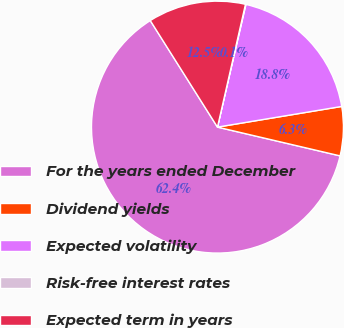Convert chart. <chart><loc_0><loc_0><loc_500><loc_500><pie_chart><fcel>For the years ended December<fcel>Dividend yields<fcel>Expected volatility<fcel>Risk-free interest rates<fcel>Expected term in years<nl><fcel>62.38%<fcel>6.29%<fcel>18.75%<fcel>0.06%<fcel>12.52%<nl></chart> 